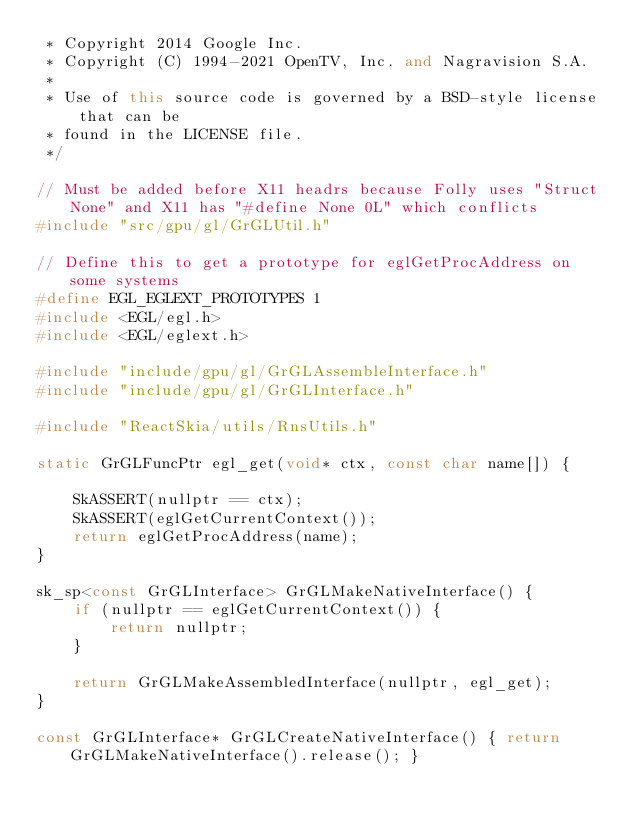<code> <loc_0><loc_0><loc_500><loc_500><_C++_> * Copyright 2014 Google Inc.
 * Copyright (C) 1994-2021 OpenTV, Inc. and Nagravision S.A.
 *
 * Use of this source code is governed by a BSD-style license that can be
 * found in the LICENSE file.
 */

// Must be added before X11 headrs because Folly uses "Struct None" and X11 has "#define None 0L" which conflicts
#include "src/gpu/gl/GrGLUtil.h"

// Define this to get a prototype for eglGetProcAddress on some systems
#define EGL_EGLEXT_PROTOTYPES 1
#include <EGL/egl.h>
#include <EGL/eglext.h>

#include "include/gpu/gl/GrGLAssembleInterface.h"
#include "include/gpu/gl/GrGLInterface.h"

#include "ReactSkia/utils/RnsUtils.h"

static GrGLFuncPtr egl_get(void* ctx, const char name[]) {

    SkASSERT(nullptr == ctx);
    SkASSERT(eglGetCurrentContext());
    return eglGetProcAddress(name);
}

sk_sp<const GrGLInterface> GrGLMakeNativeInterface() {
    if (nullptr == eglGetCurrentContext()) {
        return nullptr;
    }

    return GrGLMakeAssembledInterface(nullptr, egl_get);
}

const GrGLInterface* GrGLCreateNativeInterface() { return GrGLMakeNativeInterface().release(); }
</code> 